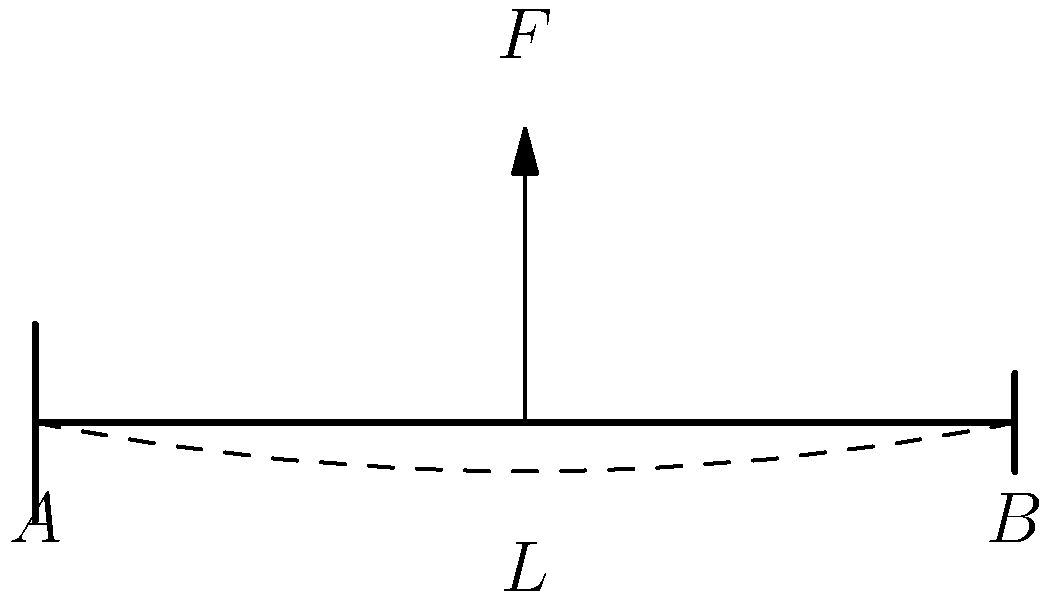In the diagram, a beam of length $L$ is supported at both ends (A and B) and has a force $F$ applied at its center. If the beam experiences a maximum deflection of 5 mm at the center, what type of stress is primarily acting on the top surface of the beam? Let's think about this step-by-step:

1. The beam is supported at both ends and has a force applied at its center, causing it to bend downward.

2. When a beam bends, the material on the top surface stretches, while the material on the bottom surface compresses.

3. The line running through the center of the beam (called the neutral axis) experiences neither stretching nor compression.

4. The stretching of the top surface causes tension in the material.

5. Tension is a type of normal stress, where forces act perpendicular to the cross-sectional area of the material.

6. The bottom surface, in contrast, experiences compressive stress.

7. While there are also shear stresses present in the beam, the question asks specifically about the top surface, where tensile stress is dominant.

Therefore, the primary stress acting on the top surface of the beam is tensile stress.
Answer: Tensile stress 